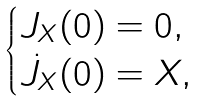Convert formula to latex. <formula><loc_0><loc_0><loc_500><loc_500>\begin{cases} J _ { X } ( 0 ) = 0 , \\ \dot { J } _ { X } ( 0 ) = X , \end{cases}</formula> 